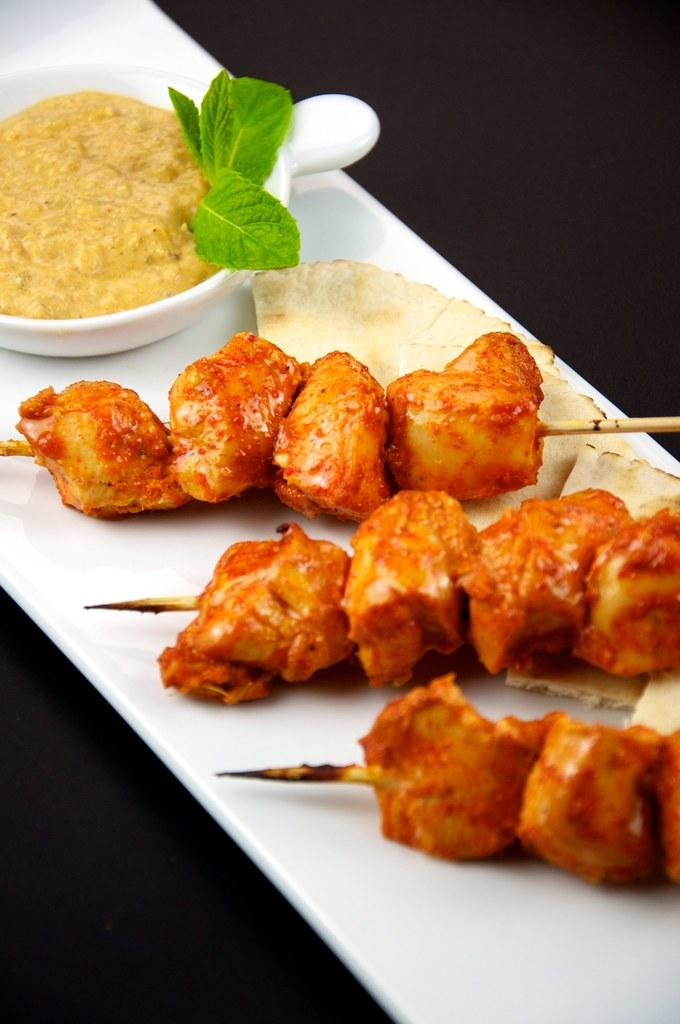What type of food can be seen in the image? There is food in the image, but the specific type cannot be determined from the provided facts. What is the food placed on in the image? There is a plate in the image. What else is present on the table or surface in the image? There is a cup in the image. How many toes are visible in the image? There are no toes visible in the image. What type of knee is shown in the image? There is no knee present in the image. 